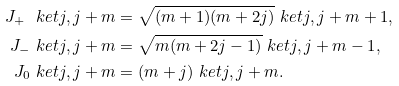Convert formula to latex. <formula><loc_0><loc_0><loc_500><loc_500>J _ { + } \ k e t { j , j + m } & = \sqrt { ( m + 1 ) ( m + 2 j ) } \ k e t { j , j + m + 1 } , \\ J _ { - } \ k e t { j , j + m } & = \sqrt { m ( m + 2 j - 1 ) } \ k e t { j , j + m - 1 } , \\ J _ { 0 } \ k e t { j , j + m } & = ( m + j ) \ k e t { j , j + m } .</formula> 